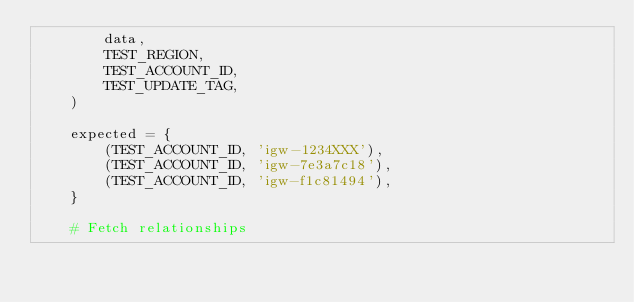Convert code to text. <code><loc_0><loc_0><loc_500><loc_500><_Python_>        data,
        TEST_REGION,
        TEST_ACCOUNT_ID,
        TEST_UPDATE_TAG,
    )

    expected = {
        (TEST_ACCOUNT_ID, 'igw-1234XXX'),
        (TEST_ACCOUNT_ID, 'igw-7e3a7c18'),
        (TEST_ACCOUNT_ID, 'igw-f1c81494'),
    }

    # Fetch relationships</code> 